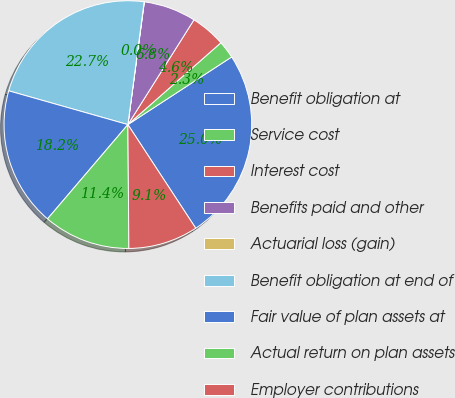Convert chart. <chart><loc_0><loc_0><loc_500><loc_500><pie_chart><fcel>Benefit obligation at<fcel>Service cost<fcel>Interest cost<fcel>Benefits paid and other<fcel>Actuarial loss (gain)<fcel>Benefit obligation at end of<fcel>Fair value of plan assets at<fcel>Actual return on plan assets<fcel>Employer contributions<nl><fcel>24.97%<fcel>2.29%<fcel>4.56%<fcel>6.83%<fcel>0.03%<fcel>22.7%<fcel>18.16%<fcel>11.36%<fcel>9.1%<nl></chart> 